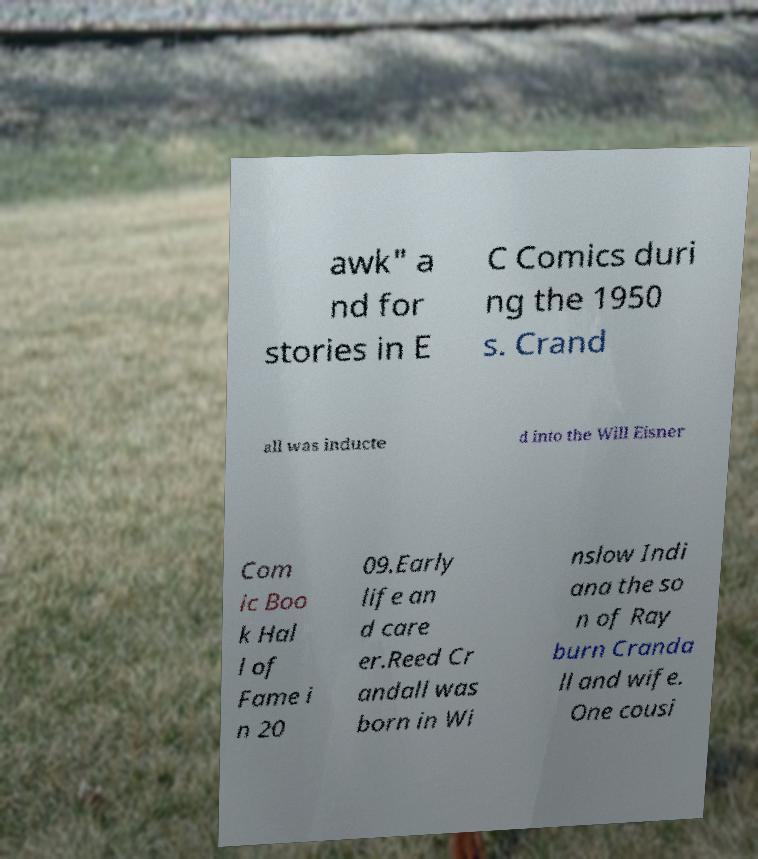Please identify and transcribe the text found in this image. awk" a nd for stories in E C Comics duri ng the 1950 s. Crand all was inducte d into the Will Eisner Com ic Boo k Hal l of Fame i n 20 09.Early life an d care er.Reed Cr andall was born in Wi nslow Indi ana the so n of Ray burn Cranda ll and wife. One cousi 